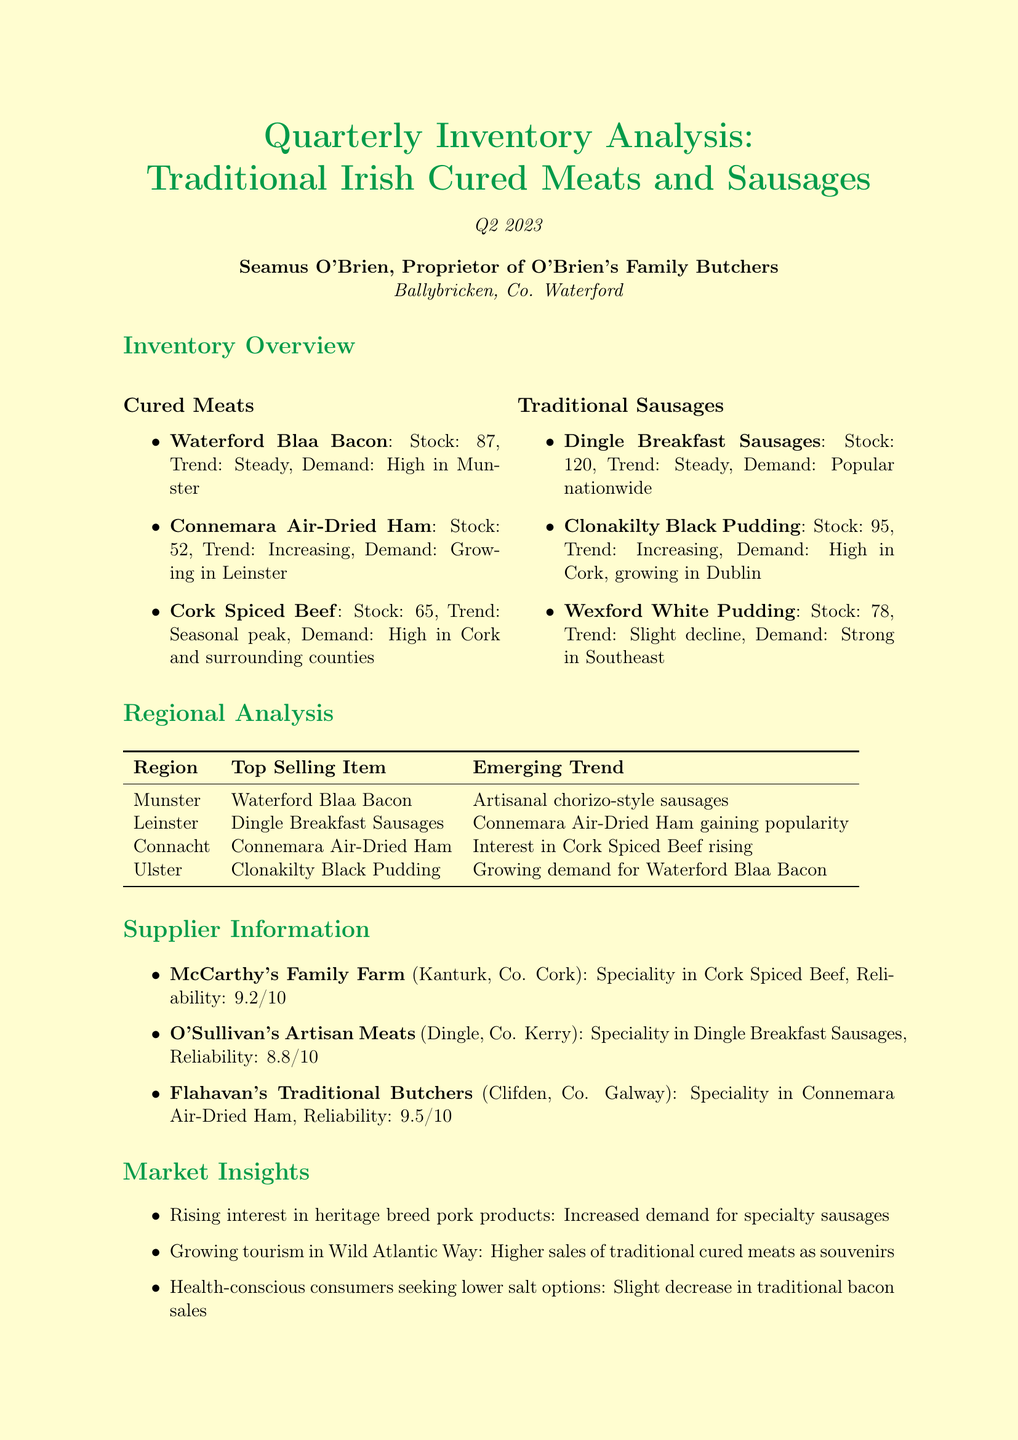What is the stock level of Waterford Blaa Bacon? The stock level for Waterford Blaa Bacon is listed under the inventory overview section.
Answer: 87 Which item has an increasing popularity trend in Leinster? The item that has an increasing popularity trend in Leinster is mentioned in the inventory analysis.
Answer: Connemara Air-Dried Ham What is the reliability score of McCarthy's Family Farm? The reliability score for McCarthy's Family Farm is mentioned in the supplier information section.
Answer: 9.2 What local event increased sales of Waterford Blaa Bacon by 50%? The local event that increased sales is noted in the local events section of the report.
Answer: Waterford Food Festival Which region's top-selling item is Clonakilty Black Pudding? The region's top-selling item is detailed in the regional analysis table.
Answer: Ulster What trend is affecting traditional bacon sales? The trend affecting traditional bacon sales is reflected in the market insights section of the document.
Answer: Health-conscious consumers seeking lower salt options What is the top-selling item in Connacht? The top-selling item in Connacht is listed in the regional analysis section.
Answer: Connemara Air-Dried Ham How many items are listed under Traditional Sausages? The number of items under Traditional Sausages is provided in the inventory overview section.
Answer: 3 Which new product line is recommended to be developed? The recommended new product line is mentioned in the conclusions and recommendations section.
Answer: Heritage breed pork 